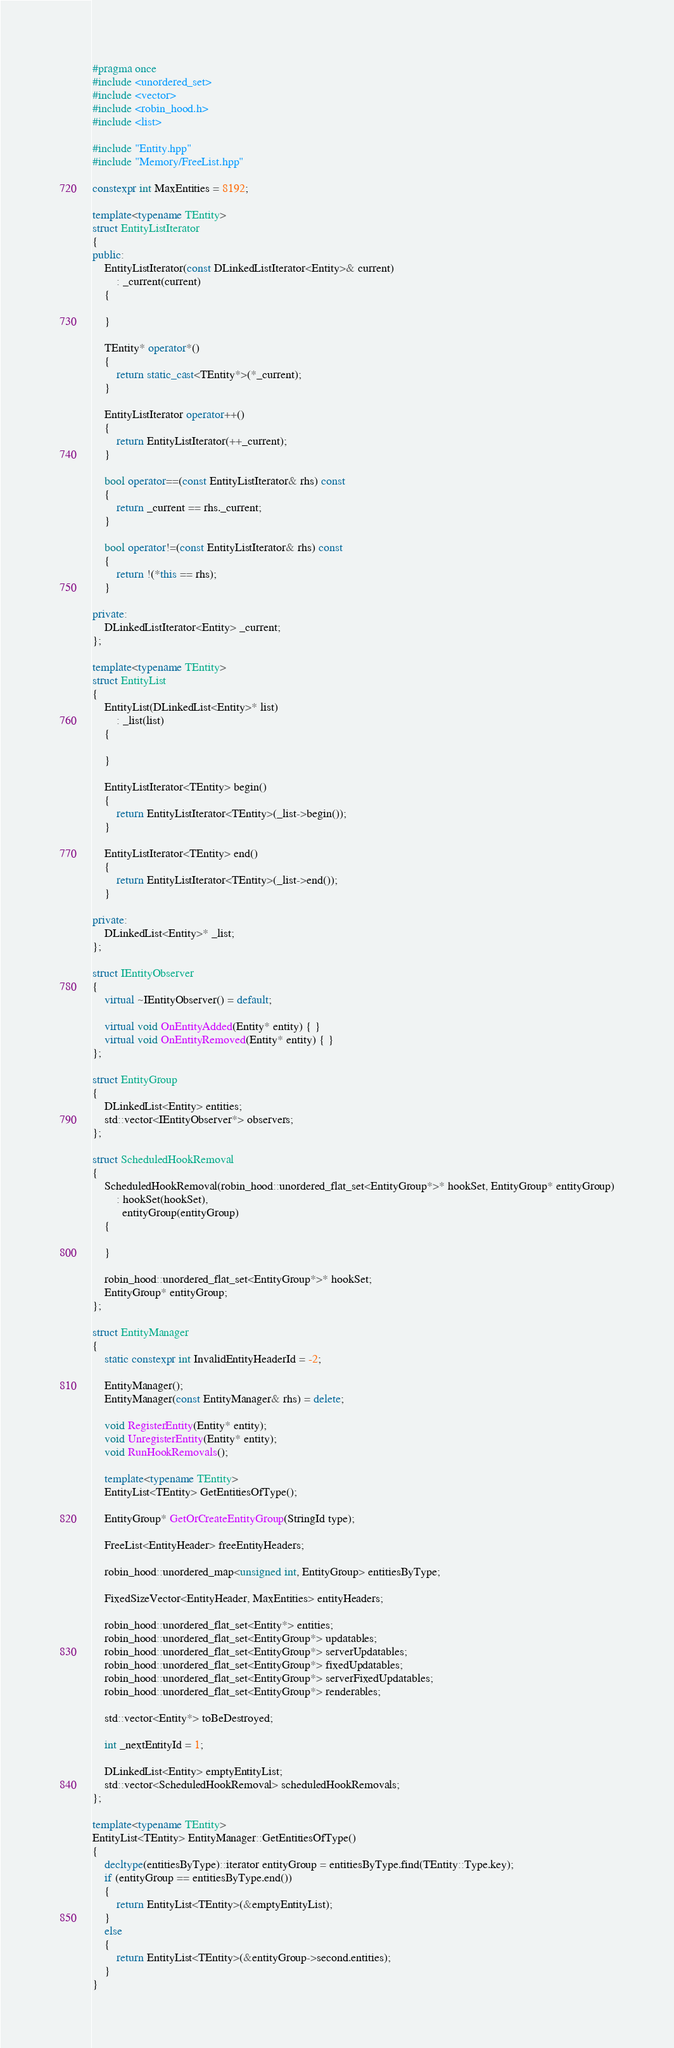<code> <loc_0><loc_0><loc_500><loc_500><_C++_>#pragma once
#include <unordered_set>
#include <vector>
#include <robin_hood.h>
#include <list>

#include "Entity.hpp"
#include "Memory/FreeList.hpp"

constexpr int MaxEntities = 8192;

template<typename TEntity>
struct EntityListIterator
{
public:
    EntityListIterator(const DLinkedListIterator<Entity>& current)
        : _current(current)
    {

    }

    TEntity* operator*()
    {
        return static_cast<TEntity*>(*_current);
    }

    EntityListIterator operator++()
    {
        return EntityListIterator(++_current);
    }

    bool operator==(const EntityListIterator& rhs) const
    {
        return _current == rhs._current;
    }

    bool operator!=(const EntityListIterator& rhs) const
    {
        return !(*this == rhs);
    }

private:
    DLinkedListIterator<Entity> _current;
};

template<typename TEntity>
struct EntityList
{
    EntityList(DLinkedList<Entity>* list)
        : _list(list)
    {

    }

    EntityListIterator<TEntity> begin()
    {
        return EntityListIterator<TEntity>(_list->begin());
    }

    EntityListIterator<TEntity> end()
    {
        return EntityListIterator<TEntity>(_list->end());
    }

private:
    DLinkedList<Entity>* _list;
};

struct IEntityObserver
{
    virtual ~IEntityObserver() = default;

    virtual void OnEntityAdded(Entity* entity) { }
    virtual void OnEntityRemoved(Entity* entity) { }
};

struct EntityGroup
{
    DLinkedList<Entity> entities;
    std::vector<IEntityObserver*> observers;
};

struct ScheduledHookRemoval
{
    ScheduledHookRemoval(robin_hood::unordered_flat_set<EntityGroup*>* hookSet, EntityGroup* entityGroup)
        : hookSet(hookSet),
          entityGroup(entityGroup)
    {

    }

    robin_hood::unordered_flat_set<EntityGroup*>* hookSet;
    EntityGroup* entityGroup;
};

struct EntityManager
{
    static constexpr int InvalidEntityHeaderId = -2;

    EntityManager();
    EntityManager(const EntityManager& rhs) = delete;

    void RegisterEntity(Entity* entity);
    void UnregisterEntity(Entity* entity);
    void RunHookRemovals();

    template<typename TEntity>
    EntityList<TEntity> GetEntitiesOfType();

    EntityGroup* GetOrCreateEntityGroup(StringId type);

    FreeList<EntityHeader> freeEntityHeaders;

    robin_hood::unordered_map<unsigned int, EntityGroup> entitiesByType;

    FixedSizeVector<EntityHeader, MaxEntities> entityHeaders;

    robin_hood::unordered_flat_set<Entity*> entities;
    robin_hood::unordered_flat_set<EntityGroup*> updatables;
    robin_hood::unordered_flat_set<EntityGroup*> serverUpdatables;
    robin_hood::unordered_flat_set<EntityGroup*> fixedUpdatables;
    robin_hood::unordered_flat_set<EntityGroup*> serverFixedUpdatables;
    robin_hood::unordered_flat_set<EntityGroup*> renderables;

    std::vector<Entity*> toBeDestroyed;

    int _nextEntityId = 1;

    DLinkedList<Entity> emptyEntityList;
    std::vector<ScheduledHookRemoval> scheduledHookRemovals;
};

template<typename TEntity>
EntityList<TEntity> EntityManager::GetEntitiesOfType()
{
    decltype(entitiesByType)::iterator entityGroup = entitiesByType.find(TEntity::Type.key);
    if (entityGroup == entitiesByType.end())
    {
        return EntityList<TEntity>(&emptyEntityList);
    }
    else
    {
        return EntityList<TEntity>(&entityGroup->second.entities);
    }
}
</code> 